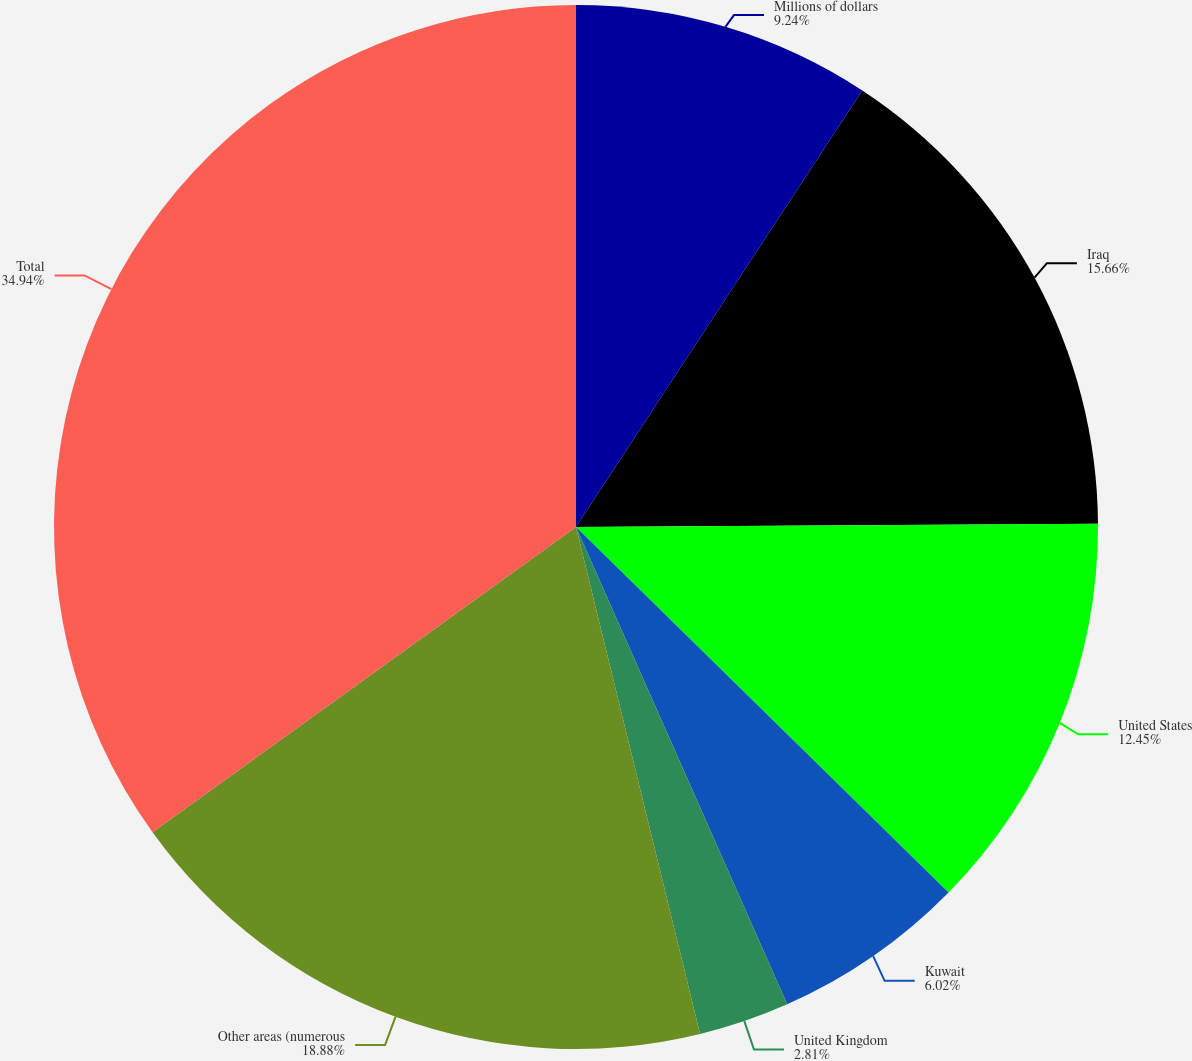<chart> <loc_0><loc_0><loc_500><loc_500><pie_chart><fcel>Millions of dollars<fcel>Iraq<fcel>United States<fcel>Kuwait<fcel>United Kingdom<fcel>Other areas (numerous<fcel>Total<nl><fcel>9.24%<fcel>15.66%<fcel>12.45%<fcel>6.02%<fcel>2.81%<fcel>18.88%<fcel>34.94%<nl></chart> 